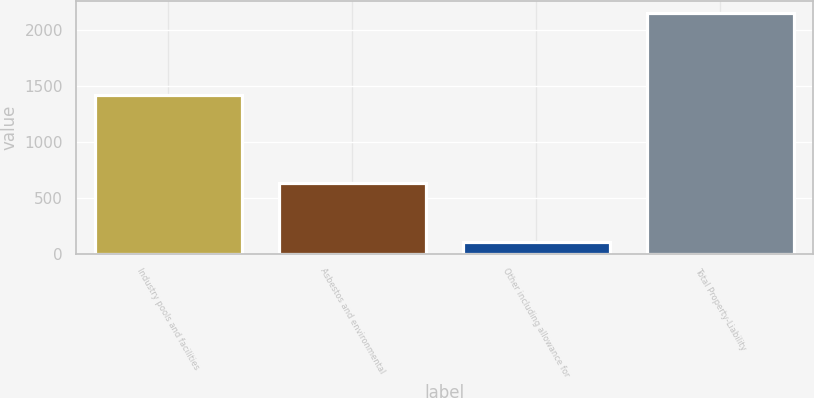Convert chart to OTSL. <chart><loc_0><loc_0><loc_500><loc_500><bar_chart><fcel>Industry pools and facilities<fcel>Asbestos and environmental<fcel>Other including allowance for<fcel>Total Property-Liability<nl><fcel>1419<fcel>628<fcel>105<fcel>2152<nl></chart> 